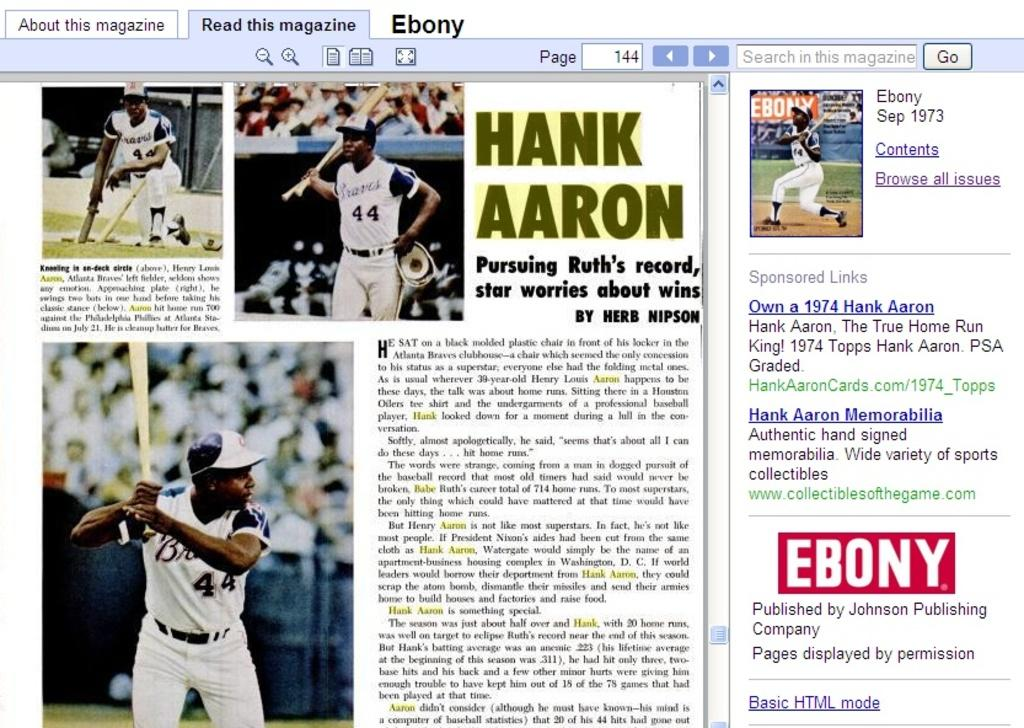<image>
Relay a brief, clear account of the picture shown. a picture of a page out of a magzine showing an article of hank aaron 